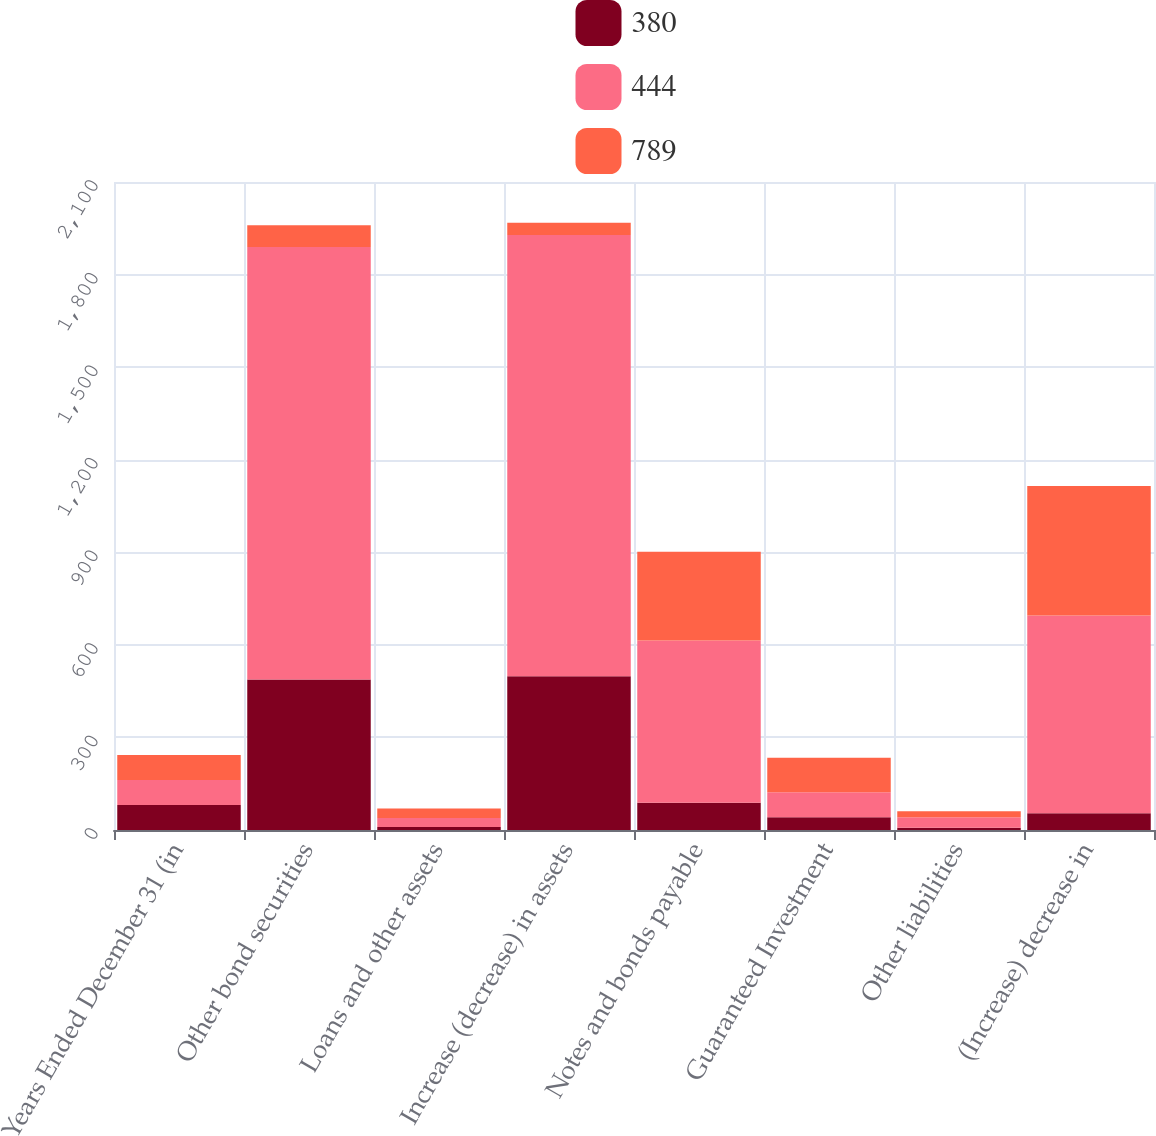<chart> <loc_0><loc_0><loc_500><loc_500><stacked_bar_chart><ecel><fcel>Years Ended December 31 (in<fcel>Other bond securities<fcel>Loans and other assets<fcel>Increase (decrease) in assets<fcel>Notes and bonds payable<fcel>Guaranteed Investment<fcel>Other liabilities<fcel>(Increase) decrease in<nl><fcel>380<fcel>81<fcel>488<fcel>10<fcel>498<fcel>88<fcel>41<fcel>7<fcel>54<nl><fcel>444<fcel>81<fcel>1401<fcel>29<fcel>1430<fcel>526<fcel>81<fcel>34<fcel>641<nl><fcel>789<fcel>81<fcel>71<fcel>31<fcel>40<fcel>288<fcel>112<fcel>20<fcel>420<nl></chart> 